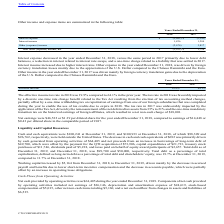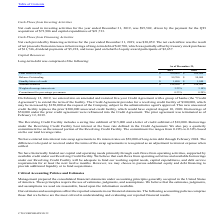According to Cts Corporation's financial document, What does the Credit Agreement provide for? revolving credit facility of $300,000, which may be increased by $150,000 at the request of the Company, subject to the administrative agent's approval.. The document states: "the facility. The Credit Agreement provides for a revolving credit facility of $300,000, which may be increased by $150,000 at the request of the Comp..." Also, What was the Total credit facility in 2019? According to the financial document, 300,000 (in thousands). The relevant text states: "Total credit facility $ 300,000 $ 300,000..." Also, What was the Standby letters of credit in 2018? According to the financial document, 1,940 (in thousands). The relevant text states: "Standby letters of credit $ 1,800 $ 1,940..." Also, can you calculate: What was the change in balance outstanding between 2018 and 2019? Based on the calculation: 99,700-50,000, the result is 49700 (in thousands). This is based on the information: "31, 2019, and December 31, 2018, was $99,700 and $50,000, respectively. Total debt as a percentage of total capitalization, defined as long-term debt as a p of December 31, 2019, and December 31, 2018..." The key data points involved are: 50,000, 99,700. Also, can you calculate: What was the change in the Weighted-average interest rate between 2018 and 2019? Based on the calculation: 3.25-3.10, the result is 0.15 (percentage). This is based on the information: "Weighted-average interest rate 3.25% 3.10% Weighted-average interest rate 3.25% 3.10%..." The key data points involved are: 3.10, 3.25. Also, can you calculate: What was the percentage change in the amount available between 2018 and 2019? To answer this question, I need to perform calculations using the financial data. The calculation is: (198,500-248,060)/248,060, which equals -19.98 (percentage). This is based on the information: "Amount available $ 198,500 $ 248,060 Amount available $ 198,500 $ 248,060..." The key data points involved are: 198,500, 248,060. 